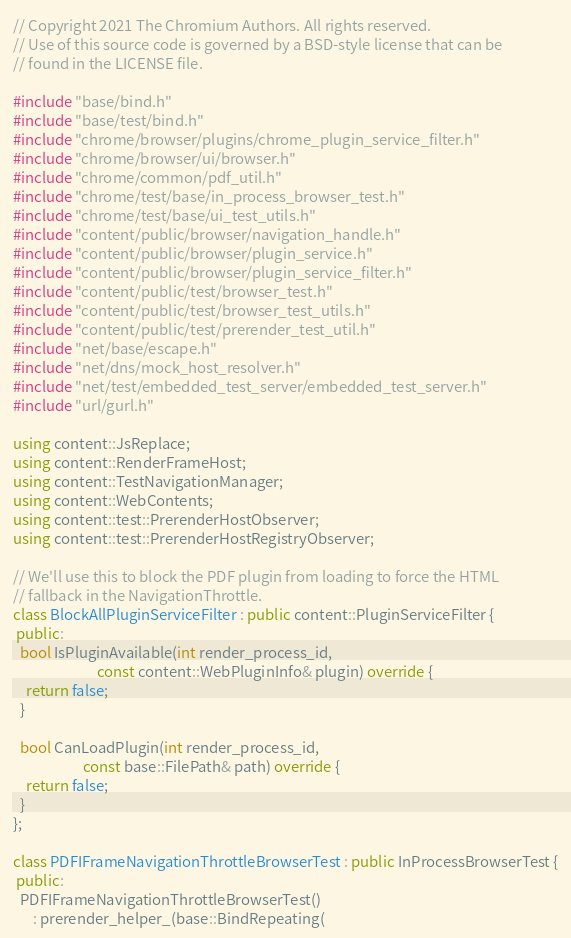<code> <loc_0><loc_0><loc_500><loc_500><_C++_>// Copyright 2021 The Chromium Authors. All rights reserved.
// Use of this source code is governed by a BSD-style license that can be
// found in the LICENSE file.

#include "base/bind.h"
#include "base/test/bind.h"
#include "chrome/browser/plugins/chrome_plugin_service_filter.h"
#include "chrome/browser/ui/browser.h"
#include "chrome/common/pdf_util.h"
#include "chrome/test/base/in_process_browser_test.h"
#include "chrome/test/base/ui_test_utils.h"
#include "content/public/browser/navigation_handle.h"
#include "content/public/browser/plugin_service.h"
#include "content/public/browser/plugin_service_filter.h"
#include "content/public/test/browser_test.h"
#include "content/public/test/browser_test_utils.h"
#include "content/public/test/prerender_test_util.h"
#include "net/base/escape.h"
#include "net/dns/mock_host_resolver.h"
#include "net/test/embedded_test_server/embedded_test_server.h"
#include "url/gurl.h"

using content::JsReplace;
using content::RenderFrameHost;
using content::TestNavigationManager;
using content::WebContents;
using content::test::PrerenderHostObserver;
using content::test::PrerenderHostRegistryObserver;

// We'll use this to block the PDF plugin from loading to force the HTML
// fallback in the NavigationThrottle.
class BlockAllPluginServiceFilter : public content::PluginServiceFilter {
 public:
  bool IsPluginAvailable(int render_process_id,
                         const content::WebPluginInfo& plugin) override {
    return false;
  }

  bool CanLoadPlugin(int render_process_id,
                     const base::FilePath& path) override {
    return false;
  }
};

class PDFIFrameNavigationThrottleBrowserTest : public InProcessBrowserTest {
 public:
  PDFIFrameNavigationThrottleBrowserTest()
      : prerender_helper_(base::BindRepeating(</code> 